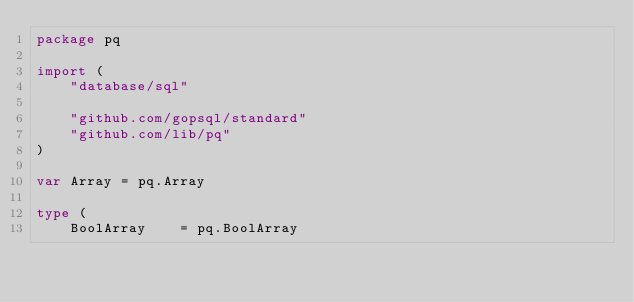Convert code to text. <code><loc_0><loc_0><loc_500><loc_500><_Go_>package pq

import (
	"database/sql"

	"github.com/gopsql/standard"
	"github.com/lib/pq"
)

var Array = pq.Array

type (
	BoolArray    = pq.BoolArray</code> 